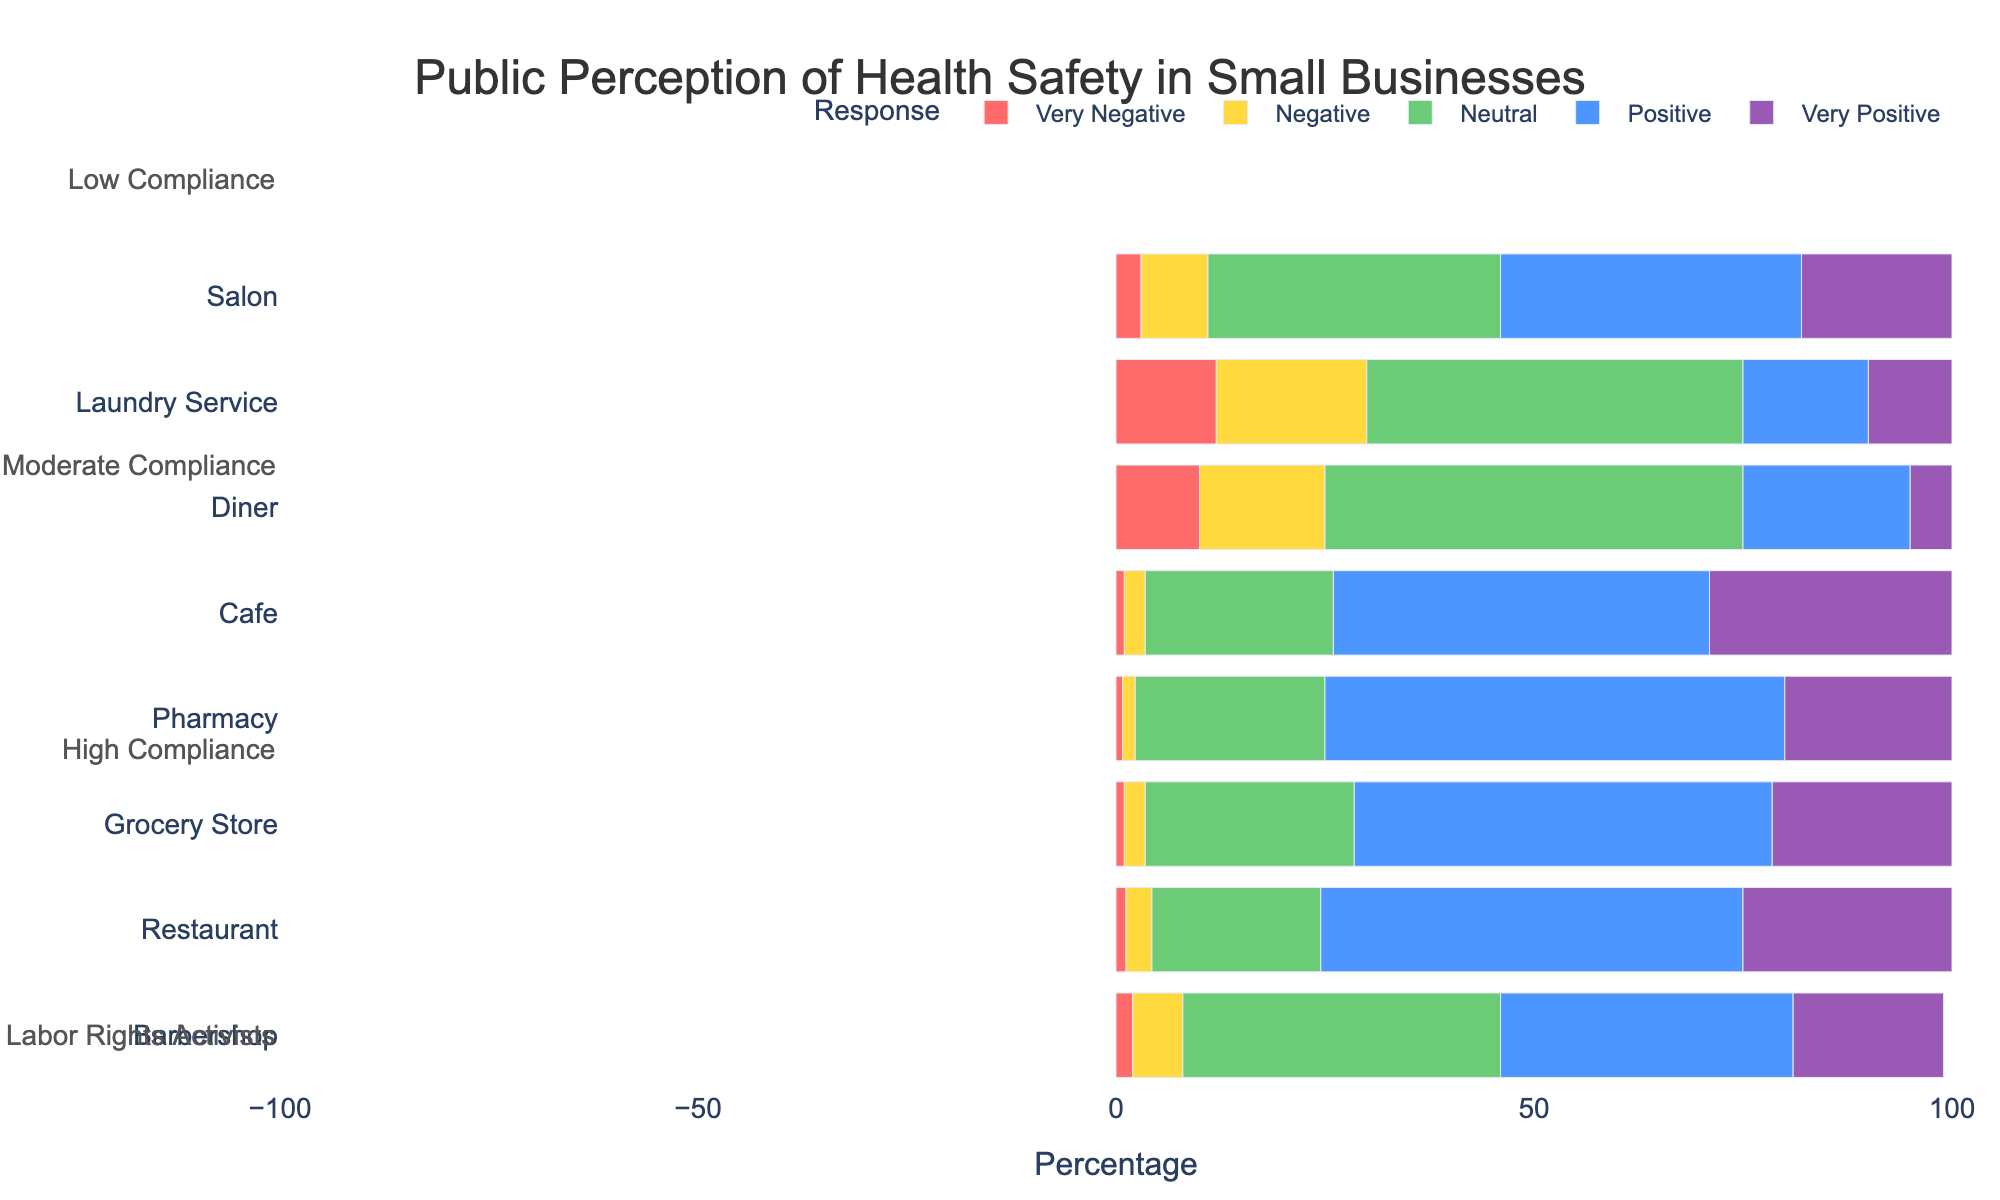What type of business has the highest percentage of 'Very Negative' response? Look at the category with the tallest bar in the 'Very Negative' section. The business type associated with the highest bar in this section is the Diner with 10% 'Very Negative' responses.
Answer: Diner Which compliance level has the most positive perception (either 'Positive' or 'Very Positive') for Grocery Stores? Compare the 'Positive' and 'Very Positive' bars for Grocery Stores across different compliance levels (high, moderate, low). The Grocery Store with High Compliance has 50% 'Positive' and 21.5% 'Very Positive'.
Answer: High Compliance How does the negative perception ('Very Negative' + 'Negative') of Laundry Service compare to Diner? Add the percentages for 'Very Negative' and 'Negative' responses for both, then compare the sums. For Laundry Service, it's 12% + 18% = 30%. For Diner, it's 10% + 15% = 25%. So, Laundry Service has a higher negative perception than Diner.
Answer: Laundry Service has a higher negative perception What percentage of respondents view Cafes very positively? Check the length of the 'Very Positive' bar for Cafes. It indicates a 29% 'Very Positive' response.
Answer: 29% Which compliance level generally has the highest neutral perception across different business types? Compare the lengths of the 'Neutral' bars for each compliance level across different businesses. Moderate Compliance shows the highest tendency towards neutrality, evident with high 'Neutral' values for Barbershops (38%) and Salons (35%).
Answer: Moderate Compliance Does any business type have a higher percentage of 'Positive' perception than 'Neutral' perception? Compare the lengths of the 'Positive' and 'Neutral' bars within the same business type. Restaurants under High Compliance have 50.5% 'Positive', which is higher than their 'Neutral' perception of 20.2%.
Answer: Restaurant (High Compliance) Which business type has the most balanced perception (similar lengths for 'Very Negative', 'Negative', 'Neutral', 'Positive', and 'Very Positive')? Examine the business type where the bars are closest in length across all response categories. The Salon with Moderate Compliance has relatively balanced bars: Very Negative (3%), Negative (8%), Neutral (35%), Positive (36%), Very Positive (18%).
Answer: Salon (Moderate Compliance) Which compliance levels see a majority of positive perception (sum of 'Positive' and 'Very Positive' over 50%) for both Restaurants and Cafes? Calculate the sum of 'Positive' and 'Very Positive' responses and check if it exceeds 50%. For Restaurants under High Compliance: 50.5% + 25% = 75.5%. For Cafes under all compliance levels checked, the percentages are 45% + 29% = 74%.
Answer: High Compliance Which business type has the lowest percentage of 'Very Positive' perception, and what is that percentage? Look for the shortest bar in the 'Very Positive' category. The Diner under Low Compliance has the shortest bar with 5%.
Answer: Diner (5%) How do perceptions of health safety in Phamacies compare to Laundy Services in terms of negative responses ('Very Negative' + 'Negative')? Add the percentages for 'Very Negative' and 'Negative' responses for both Pharmacy and Laundry Service. Pharmacy has 0.8% + 1.5% = 2.3% while Laundry Service has 12% + 18% = 30%. So, Laundry Service has a much higher negative perception.
Answer: Laundry Service has a much higher negative perception 